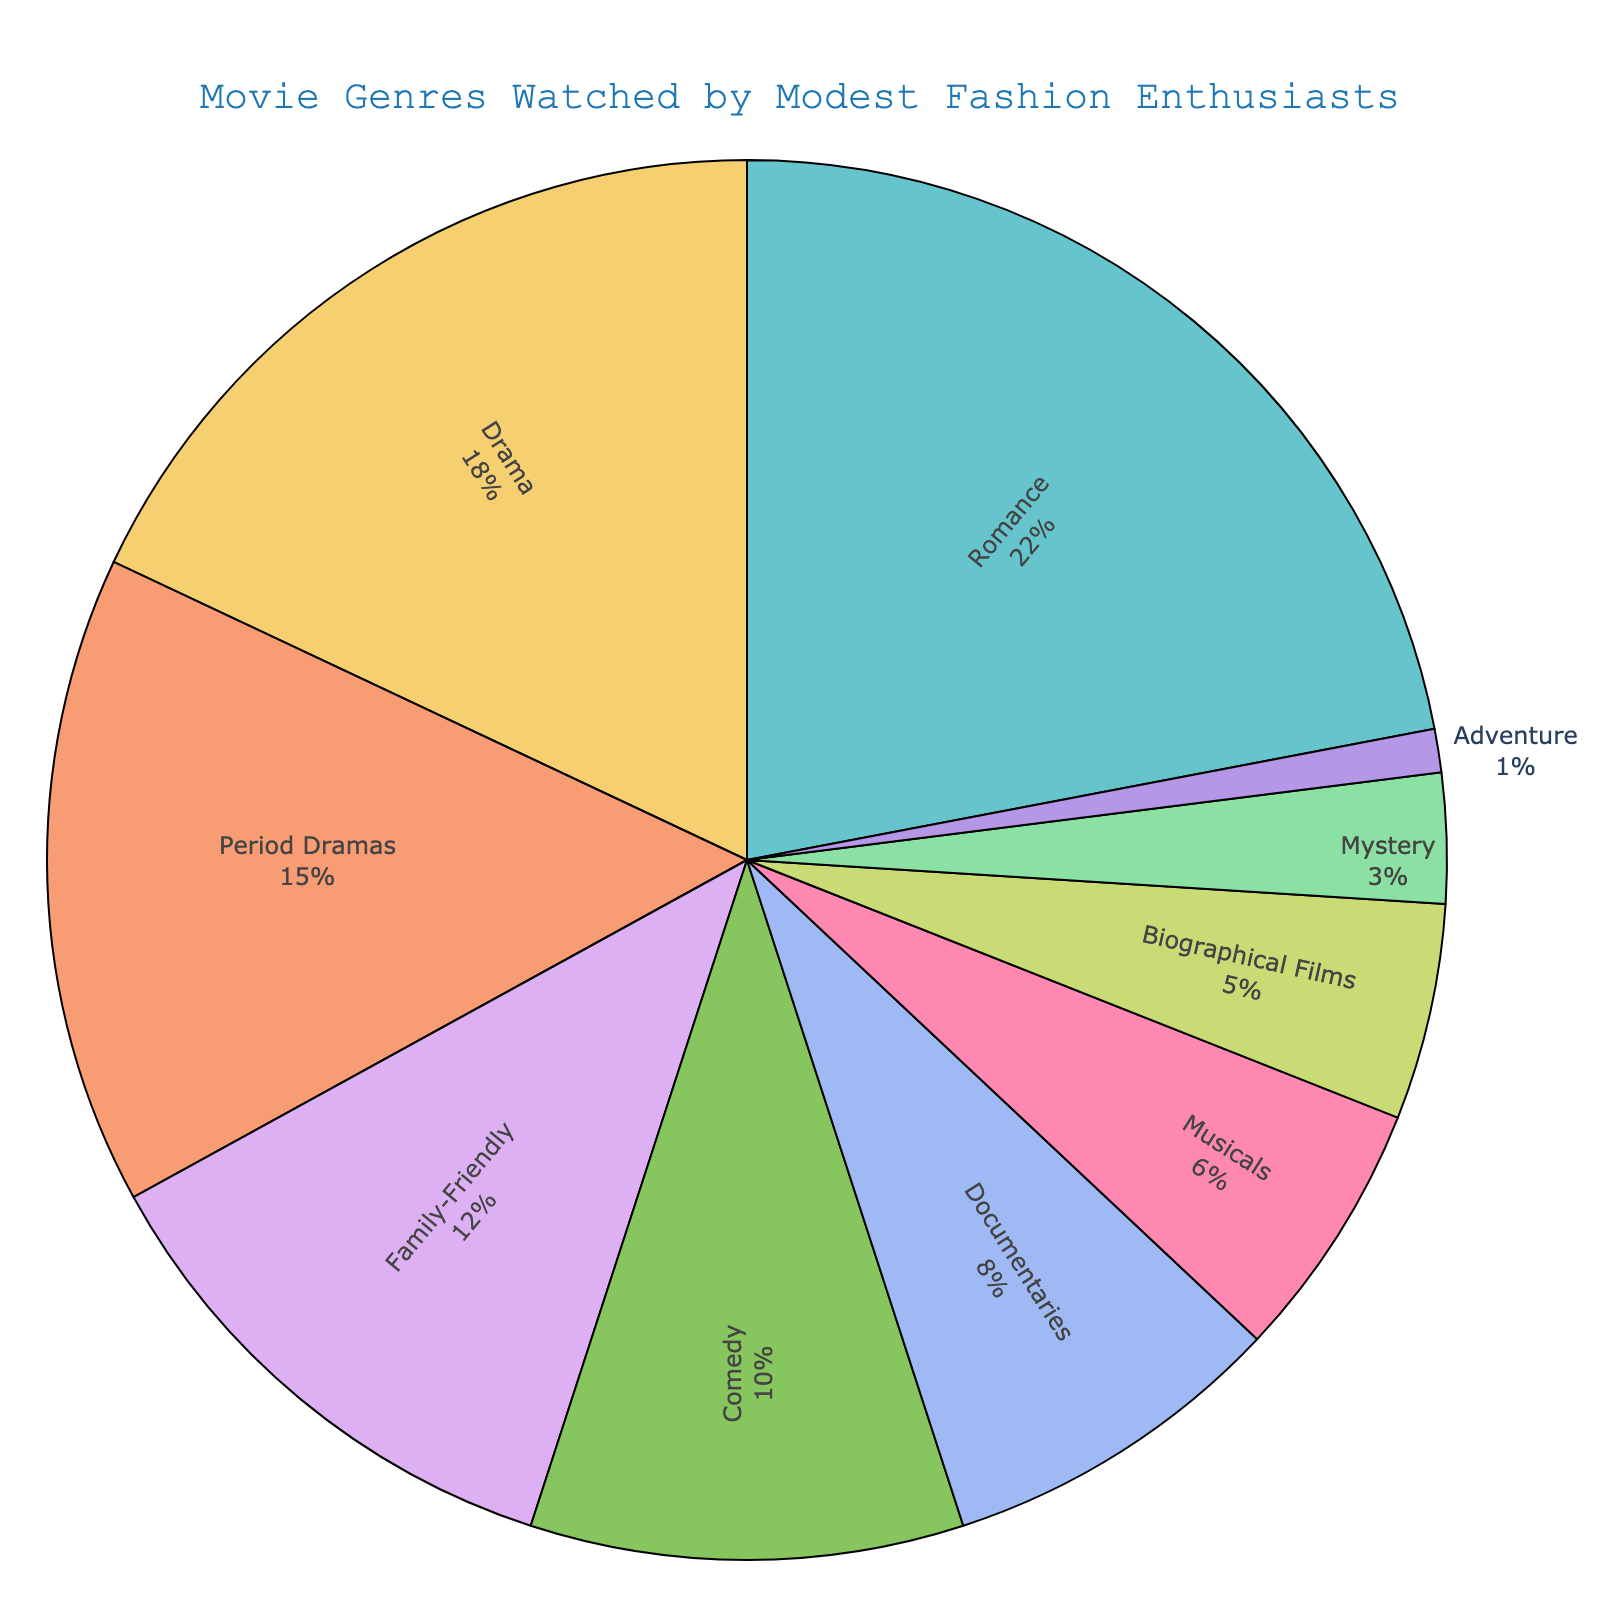What's the most popular movie genre among modest fashion enthusiasts? The chart shows that the Romance genre has the largest percentage segment, indicating it is the most popular.
Answer: Romance Which two genres have the closest percentage values? The chart shows Drama at 18% and Period Dramas at 15%, which are the closest in value.
Answer: Drama and Period Dramas What is the combined percentage of Romance and Family-Friendly genres? The Romance genre is 22%, and Family-Friendly is 12%. Their combined percentage is 22 + 12 = 34%.
Answer: 34% Which genre has a smaller percentage, Musicals or Documentaries? The chart shows Musicals at 6% and Documentaries at 8%. So, Musicals has a smaller percentage.
Answer: Musicals If you combine the percentages of Biographical Films and Mystery, is it greater than the percentage of Comedies? Biographical Films have 5%, and Mystery has 3%. Combined is 5 + 3 = 8%. Since Comedies have 10%, combined (8%) is not greater than Comedies (10%).
Answer: No How much is the difference between the percentages of the most and least watched genres? The most watched genre is Romance with 22%, and the least watched is Adventure with 1%. The difference is 22 - 1 = 21%.
Answer: 21% What is the average percentage of the top three genres? The top three genres are Romance (22%), Drama (18%), and Period Dramas (15%). Average is (22 + 18 + 15) / 3 = 18.33%.
Answer: 18.33% Which genre is illustrated in darker color, Musicals or Documentaries? Usually, Documentaries are highlighted with a darker shade than lighter-toned Musicals.
Answer: Documentaries What is the total percentage of genres categorized as less than 10% each? The genres below 10% are Documentaries (8%), Musicals (6%), Biographical Films (5%), Mystery (3%), and Adventure (1%). Total is 8 + 6 + 5 + 3 + 1 = 23%.
Answer: 23% Does Mystery have a higher percentage than Adventure? Mystery is shown with 3%, whereas Adventure has 1%. Thus, Mystery has a higher percentage.
Answer: Yes 